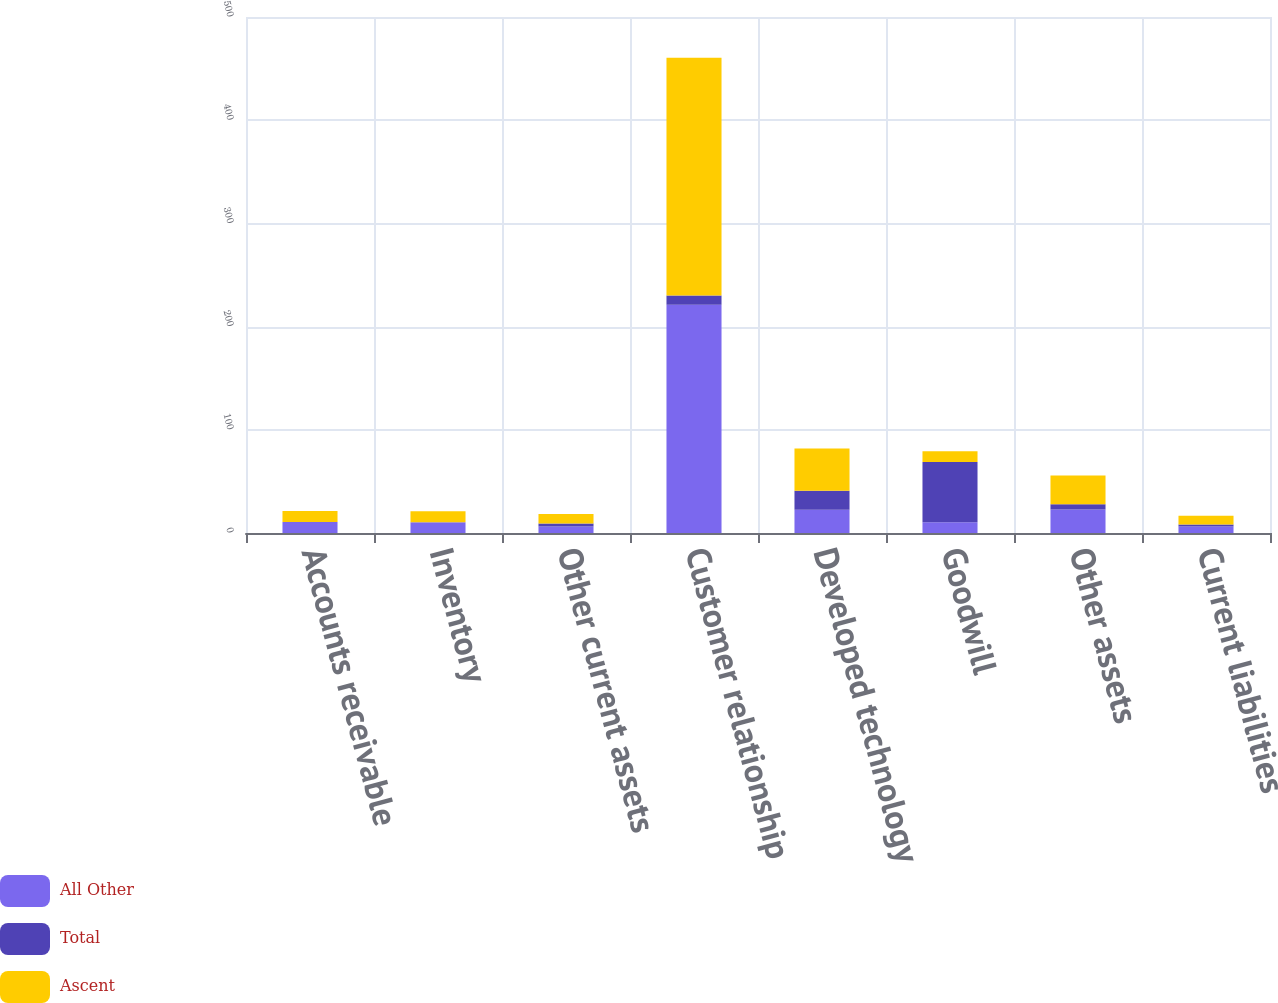Convert chart. <chart><loc_0><loc_0><loc_500><loc_500><stacked_bar_chart><ecel><fcel>Accounts receivable<fcel>Inventory<fcel>Other current assets<fcel>Customer relationship<fcel>Developed technology<fcel>Goodwill<fcel>Other assets<fcel>Current liabilities<nl><fcel>All Other<fcel>10.6<fcel>10.3<fcel>6.3<fcel>221.1<fcel>22.5<fcel>10.4<fcel>22.7<fcel>6.3<nl><fcel>Total<fcel>0.1<fcel>0.2<fcel>2.9<fcel>9.1<fcel>18.5<fcel>58.4<fcel>5.2<fcel>2<nl><fcel>Ascent<fcel>10.7<fcel>10.5<fcel>9.2<fcel>230.2<fcel>41<fcel>10.4<fcel>27.9<fcel>8.3<nl></chart> 